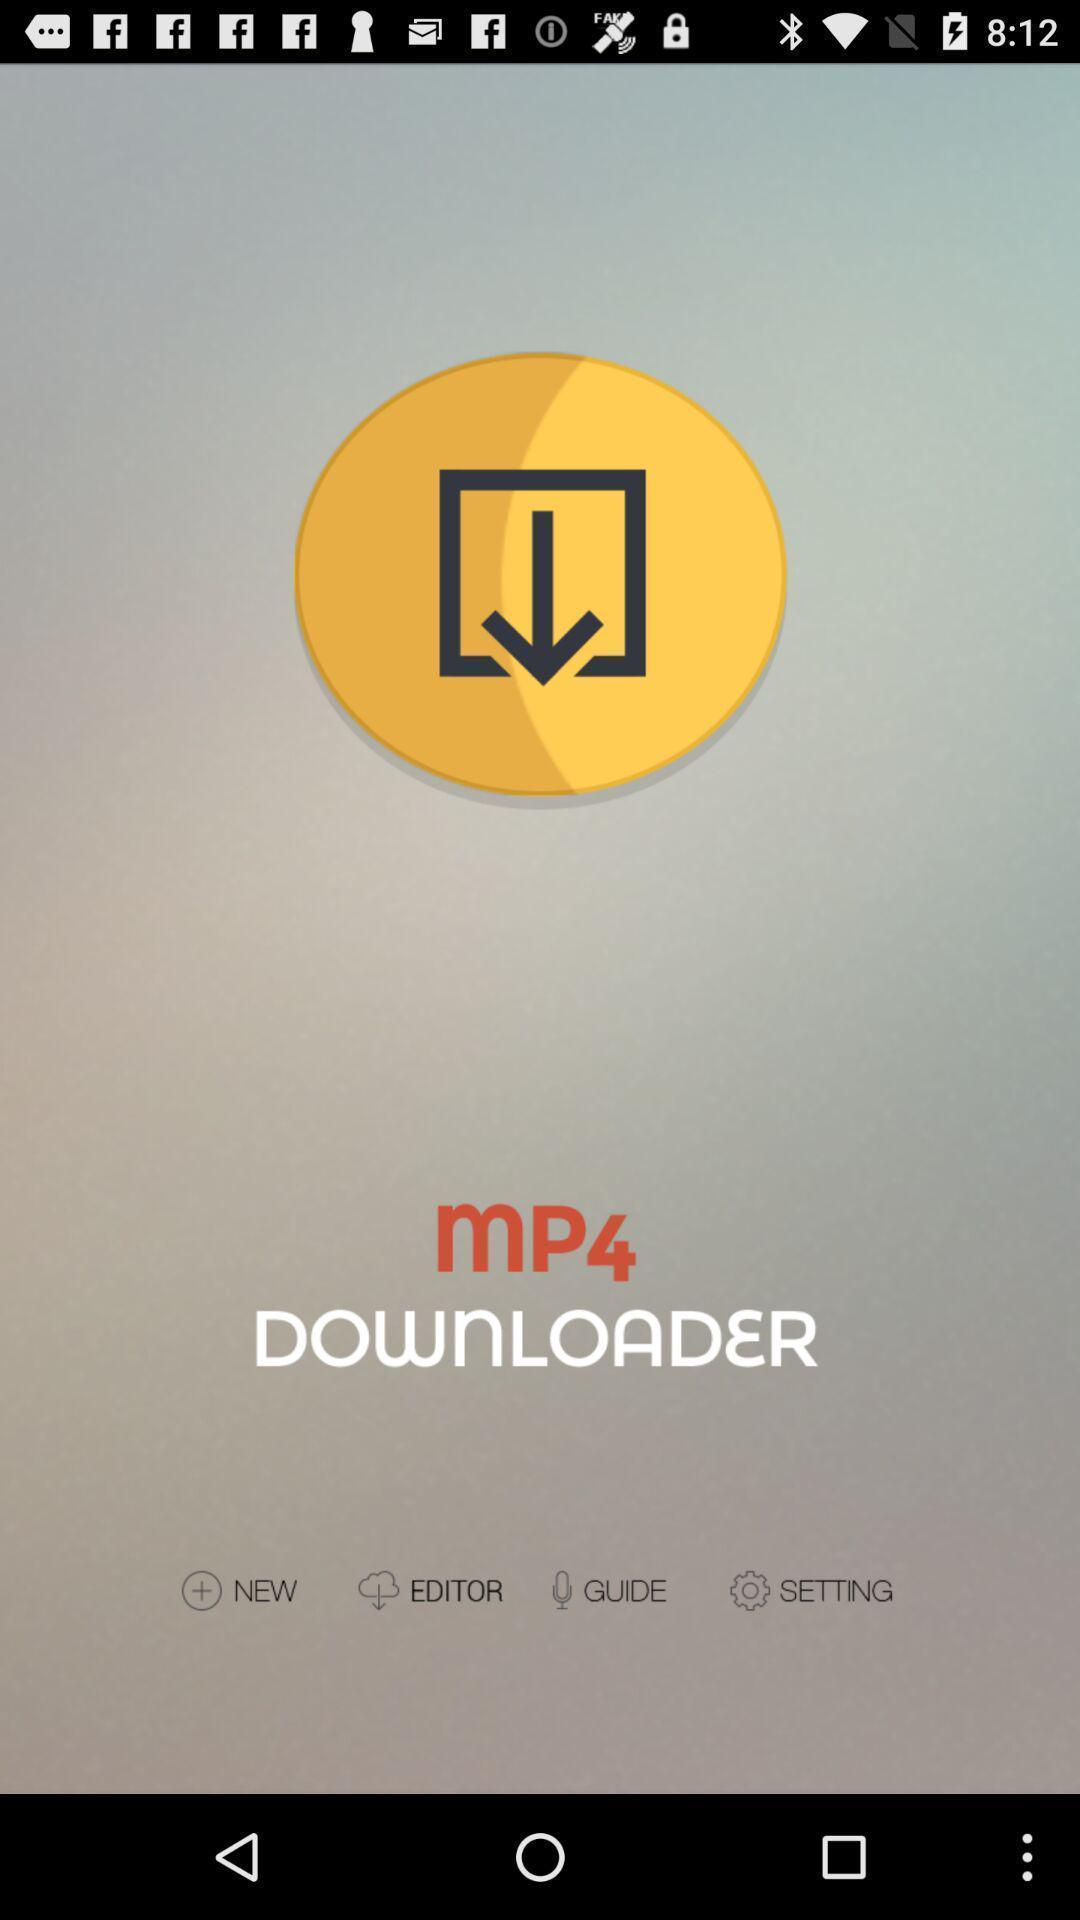What can you discern from this picture? Welcome page of the app. 